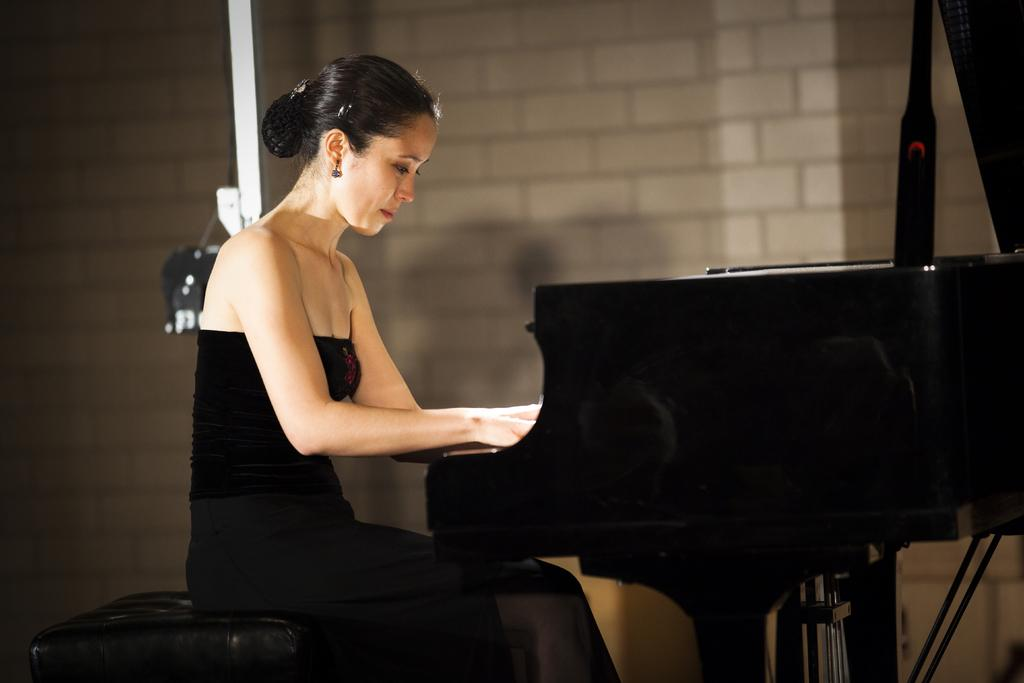Who is the main subject in the image? There is a woman in the image. What is the woman doing in the image? The woman is sitting on a chair and playing a musical instrument. What can be seen in the background of the image? There is a white color wall in the background of the image. Is there a squirrel pulling a drawer in the image? No, there is no squirrel or drawer present in the image. 